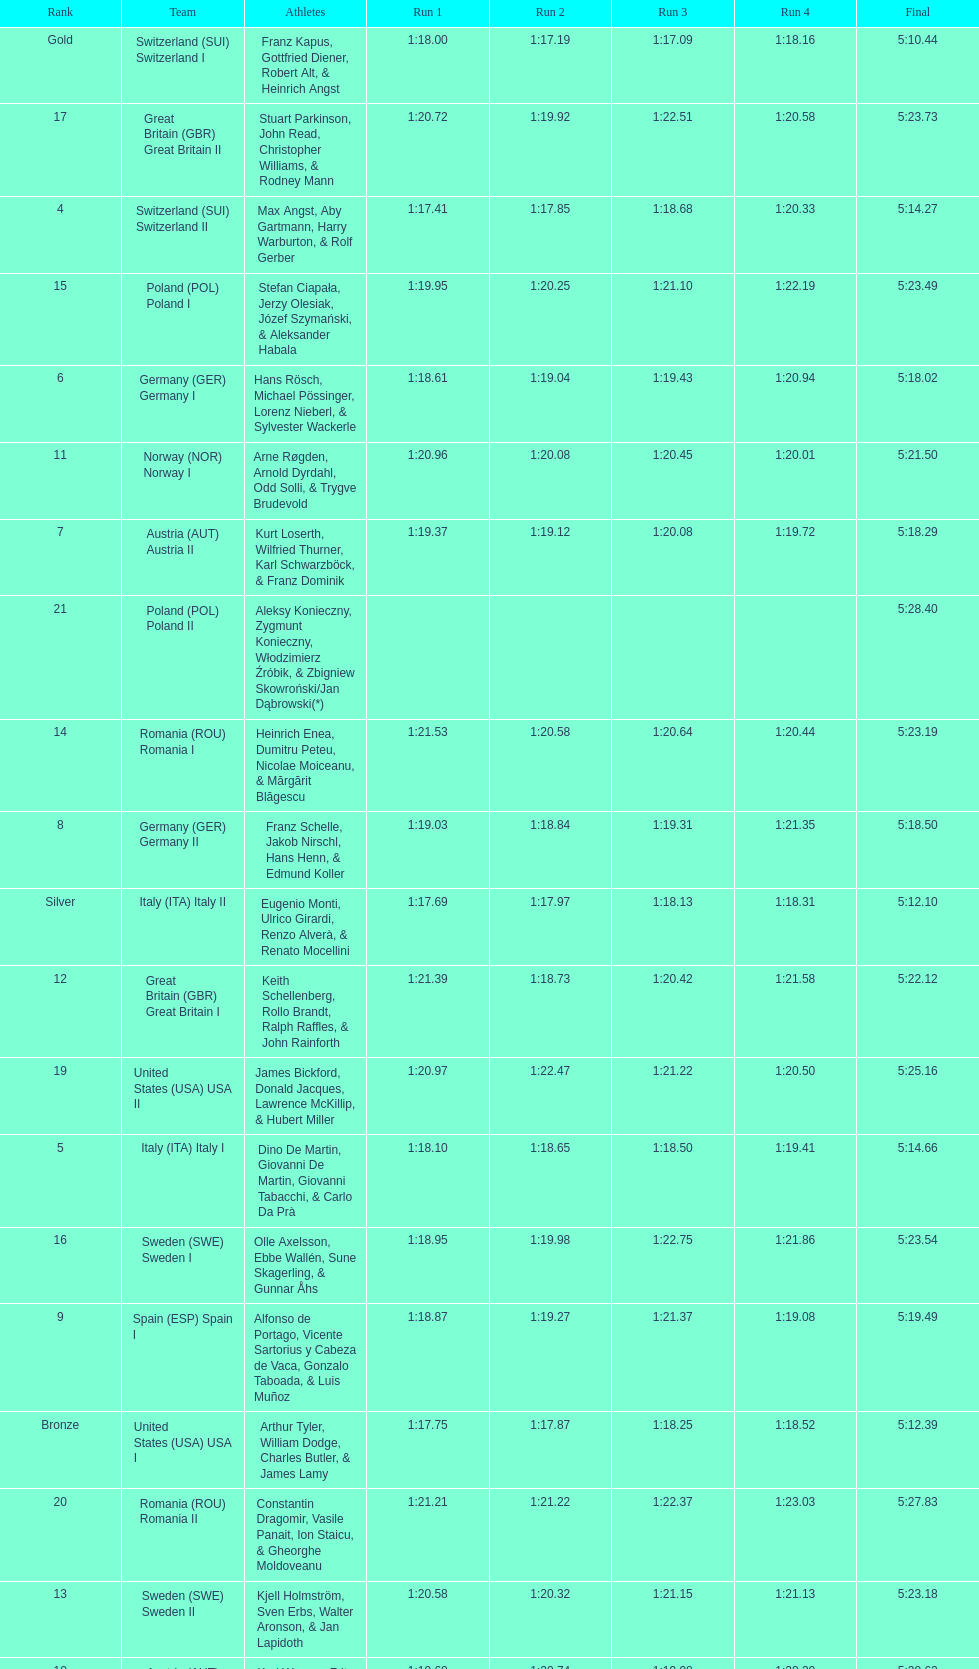What team came out on top? Switzerland. 